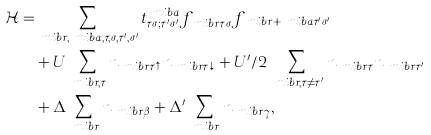Convert formula to latex. <formula><loc_0><loc_0><loc_500><loc_500>\mathcal { H } = & \sum _ { \ m i b { r } , \ m i b { a } , \tau , \sigma , \tau ^ { \prime } , \sigma ^ { \prime } } t ^ { \ m i b { a } } _ { \tau \sigma ; \tau ^ { \prime } \sigma ^ { \prime } } f ^ { \dagger } _ { \ m i b { r } \tau \sigma } f _ { \ m i b { r } + \ m i b { a } \tau ^ { \prime } \sigma ^ { \prime } } \\ & + U \sum _ { \ m i b { r } , \tau } n _ { \ m i b { r } \tau \uparrow } n _ { \ m i b { r } \tau \downarrow } + U ^ { \prime } / 2 \sum _ { \ m i b { r } , \tau \ne \tau ^ { \prime } } n _ { \ m i b { r } \tau } n _ { \ m i b { r } \tau ^ { \prime } } \\ & + \Delta \sum _ { \ m i b { r } } n _ { \ m i b { r } \beta } + \Delta ^ { \prime } \sum _ { \ m i b { r } } n _ { \ m i b { r } \gamma } ,</formula> 